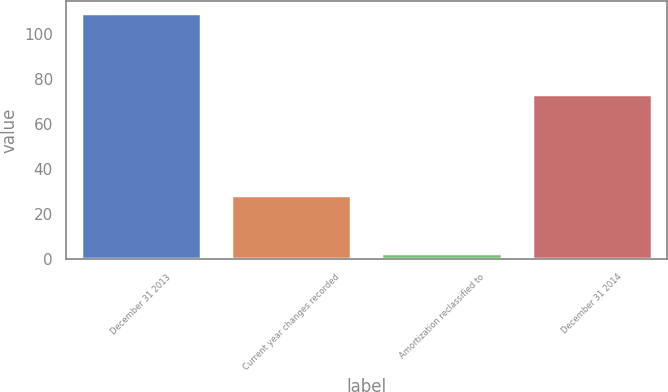Convert chart. <chart><loc_0><loc_0><loc_500><loc_500><bar_chart><fcel>December 31 2013<fcel>Current year changes recorded<fcel>Amortization reclassified to<fcel>December 31 2014<nl><fcel>109.5<fcel>28.4<fcel>2.9<fcel>73.4<nl></chart> 